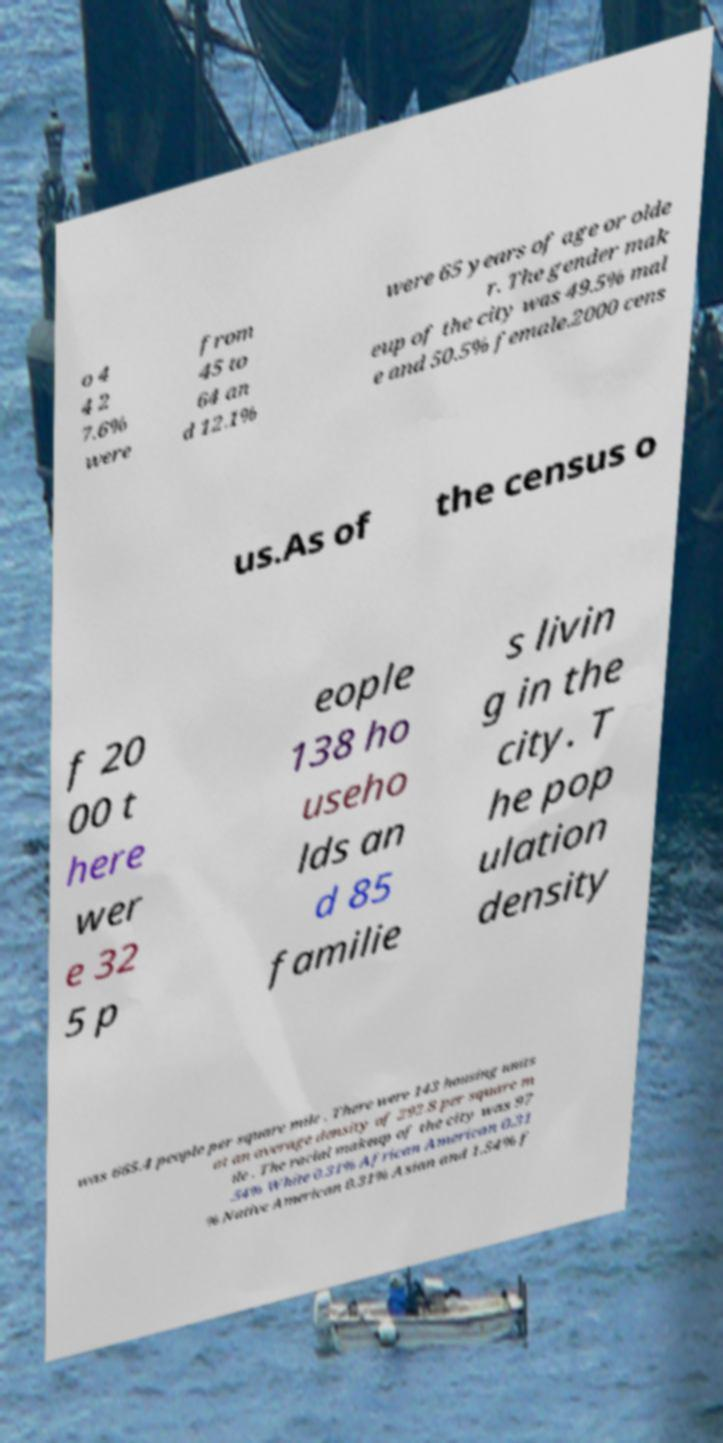Please identify and transcribe the text found in this image. o 4 4 2 7.6% were from 45 to 64 an d 12.1% were 65 years of age or olde r. The gender mak eup of the city was 49.5% mal e and 50.5% female.2000 cens us.As of the census o f 20 00 t here wer e 32 5 p eople 138 ho useho lds an d 85 familie s livin g in the city. T he pop ulation density was 665.4 people per square mile . There were 143 housing units at an average density of 292.8 per square m ile . The racial makeup of the city was 97 .54% White 0.31% African American 0.31 % Native American 0.31% Asian and 1.54% f 